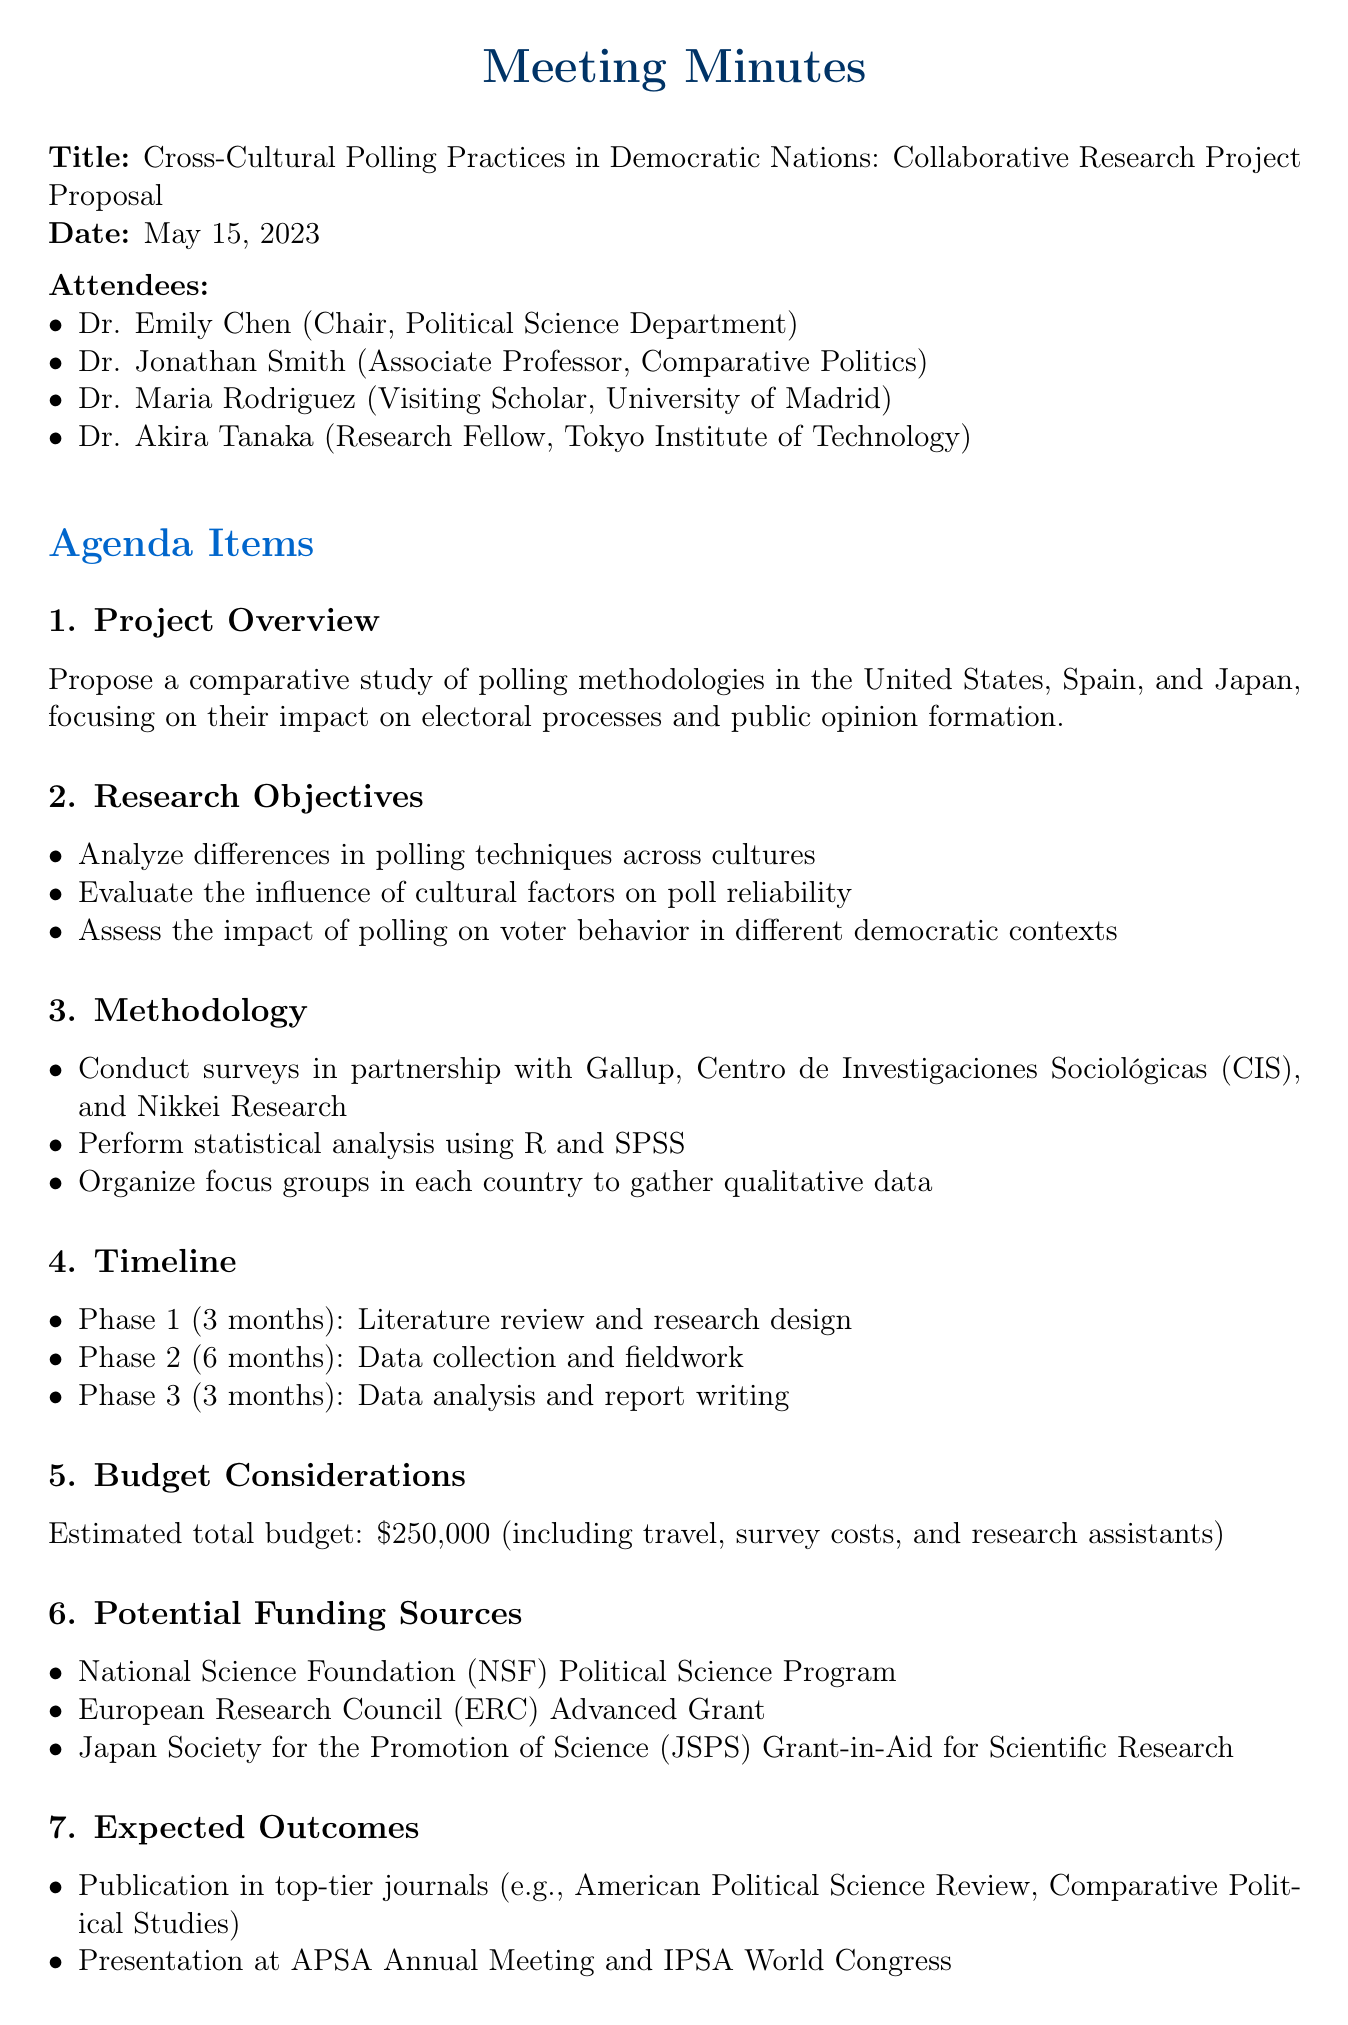What is the title of the meeting? The title of the meeting can be found at the beginning of the document.
Answer: Cross-Cultural Polling Practices in Democratic Nations: Collaborative Research Project Proposal Who are attending the meeting? Attendees are listed in the document, providing names and titles.
Answer: Dr. Emily Chen, Dr. Jonathan Smith, Dr. Maria Rodriguez, Dr. Akira Tanaka How long is Phase 1 of the research timeline? The timeline section specifies the duration of each phase.
Answer: 3 months What is the estimated total budget for the project? The budget is mentioned under the budget considerations section of the document.
Answer: $250,000 Which organization is mentioned as a potential funding source? Potential funding sources are listed, and any specific organization can be cited.
Answer: National Science Foundation (NSF) Political Science Program What is one expected outcome of the project? Expected outcomes are provided, and any specific result can be cited.
Answer: Publication in top-tier journals What will Dr. Chen do by June 1, 2023? The action items specify responsibilities and deadlines for attendees.
Answer: Finalize research proposal How will qualitative data be gathered? The methodology section outlines approaches for data collection.
Answer: Organize focus groups 